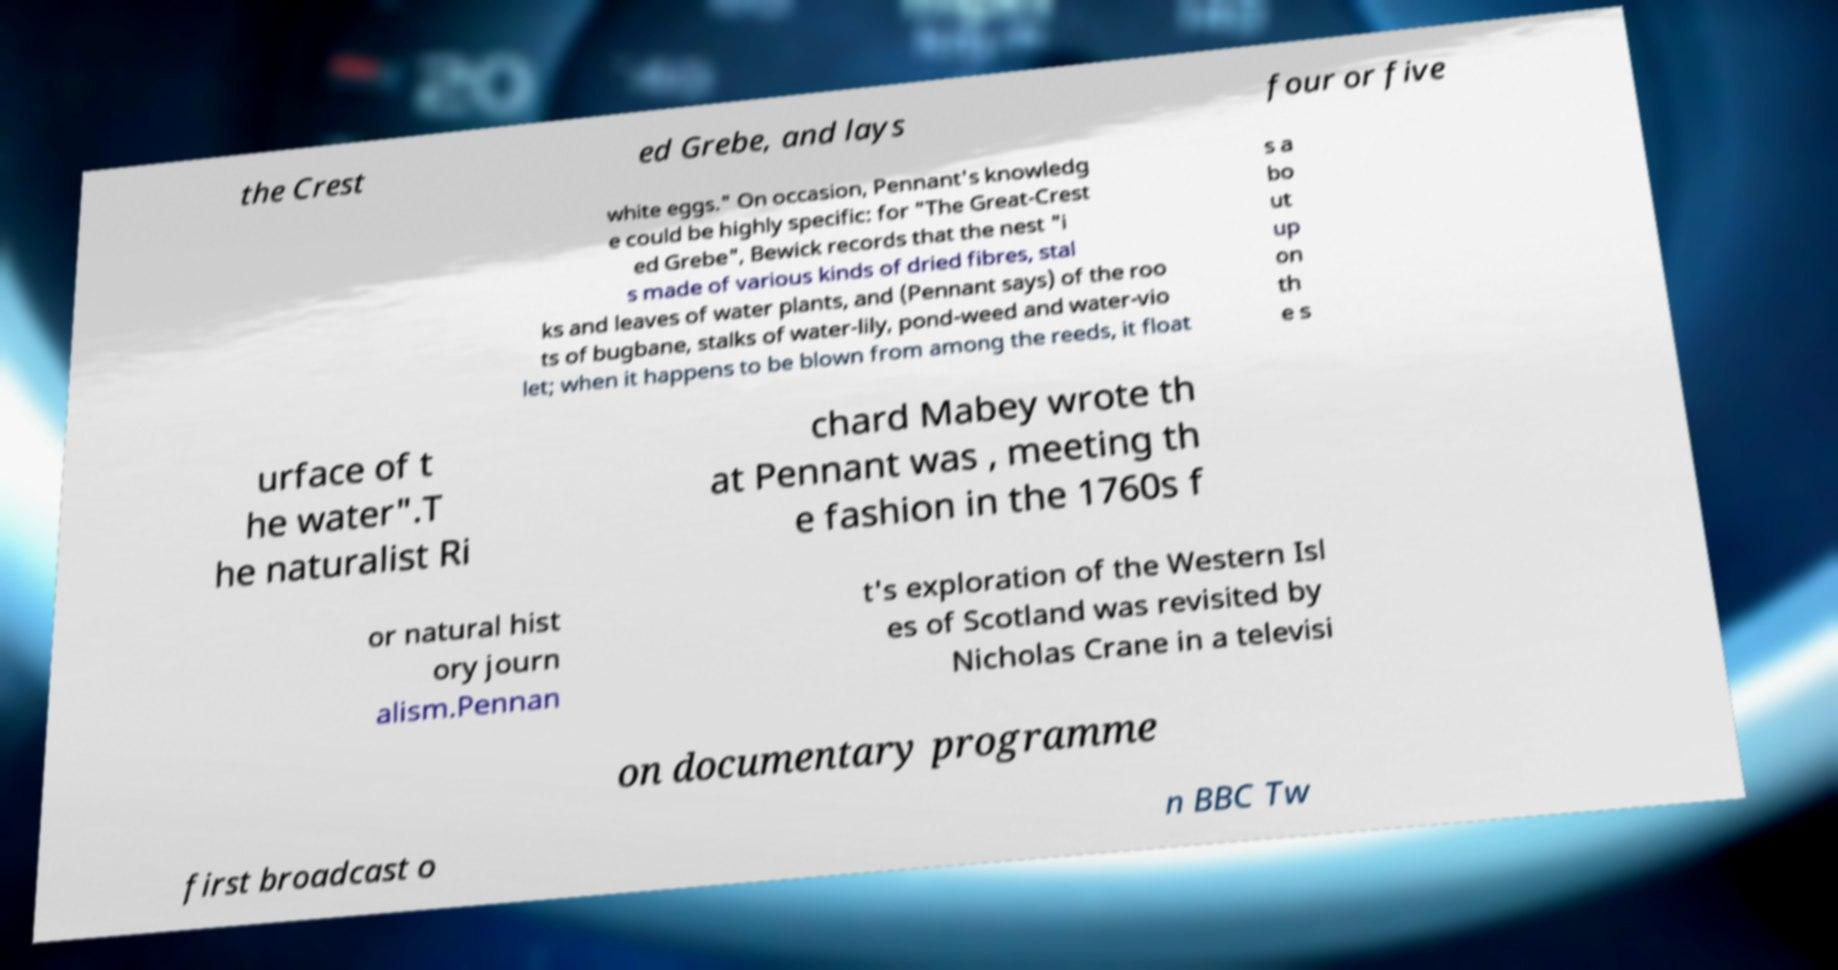Please identify and transcribe the text found in this image. the Crest ed Grebe, and lays four or five white eggs." On occasion, Pennant's knowledg e could be highly specific: for "The Great-Crest ed Grebe", Bewick records that the nest "i s made of various kinds of dried fibres, stal ks and leaves of water plants, and (Pennant says) of the roo ts of bugbane, stalks of water-lily, pond-weed and water-vio let; when it happens to be blown from among the reeds, it float s a bo ut up on th e s urface of t he water".T he naturalist Ri chard Mabey wrote th at Pennant was , meeting th e fashion in the 1760s f or natural hist ory journ alism.Pennan t's exploration of the Western Isl es of Scotland was revisited by Nicholas Crane in a televisi on documentary programme first broadcast o n BBC Tw 